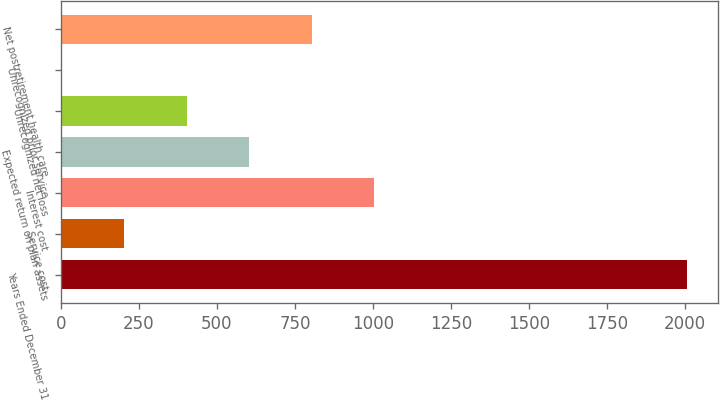<chart> <loc_0><loc_0><loc_500><loc_500><bar_chart><fcel>Years Ended December 31<fcel>Service cost<fcel>Interest cost<fcel>Expected return on plan assets<fcel>Unrecognized net loss<fcel>Unrecognized prior service<fcel>Net postretirement health care<nl><fcel>2006<fcel>202.4<fcel>1004<fcel>603.2<fcel>402.8<fcel>2<fcel>803.6<nl></chart> 